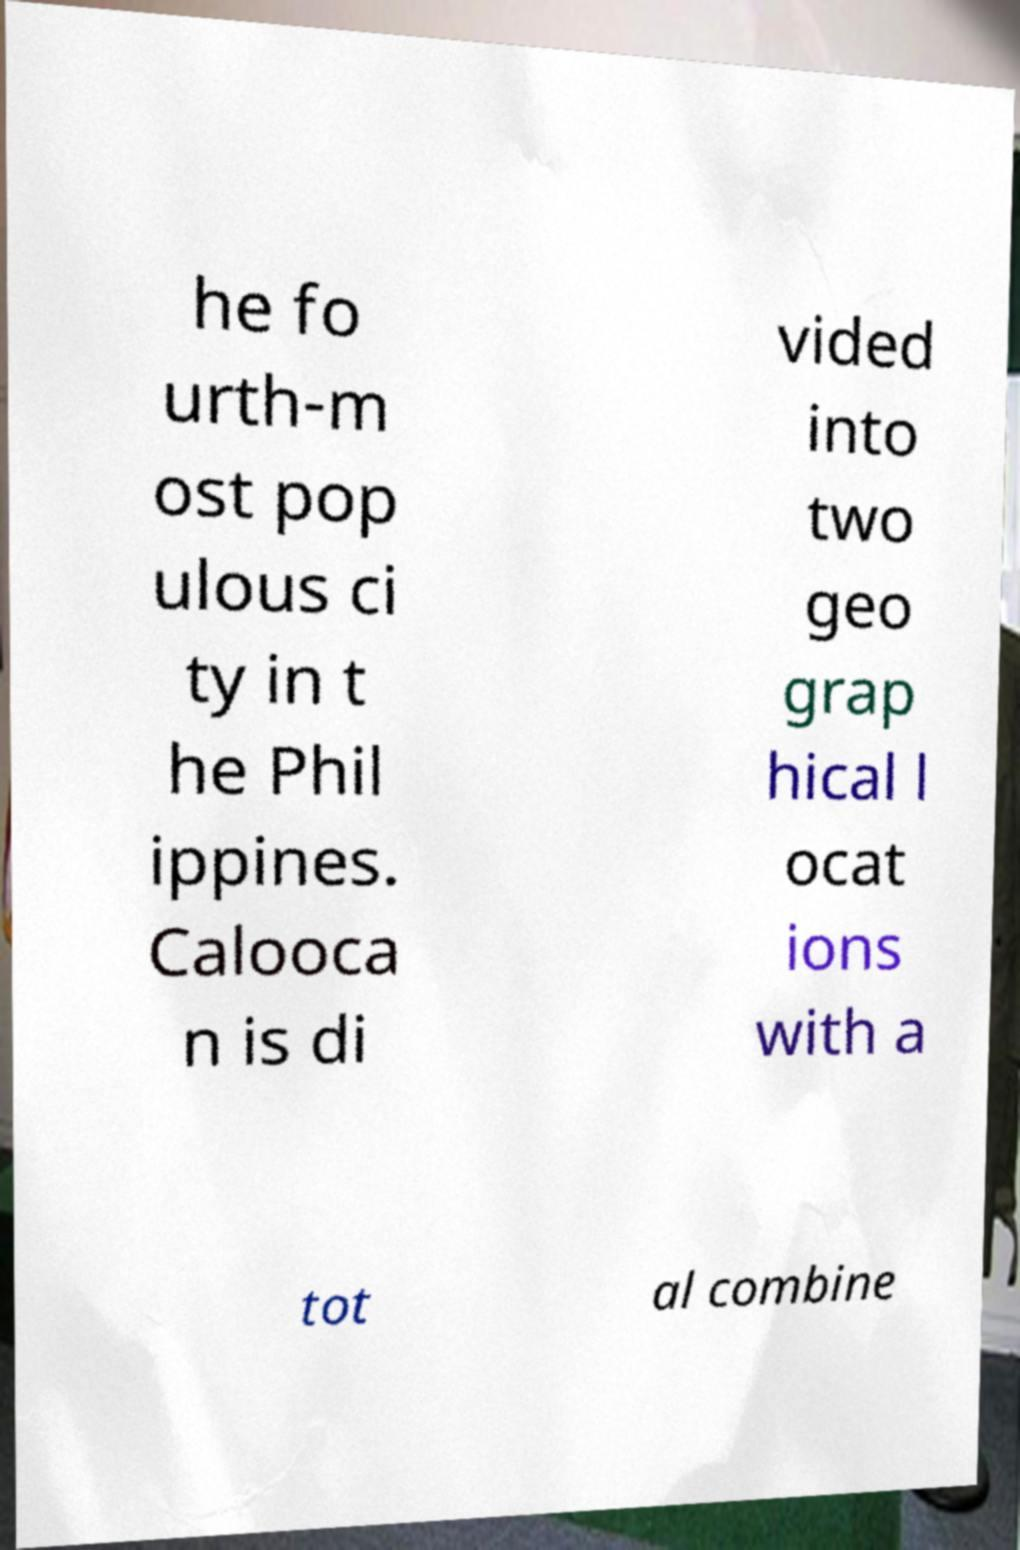Could you extract and type out the text from this image? he fo urth-m ost pop ulous ci ty in t he Phil ippines. Calooca n is di vided into two geo grap hical l ocat ions with a tot al combine 